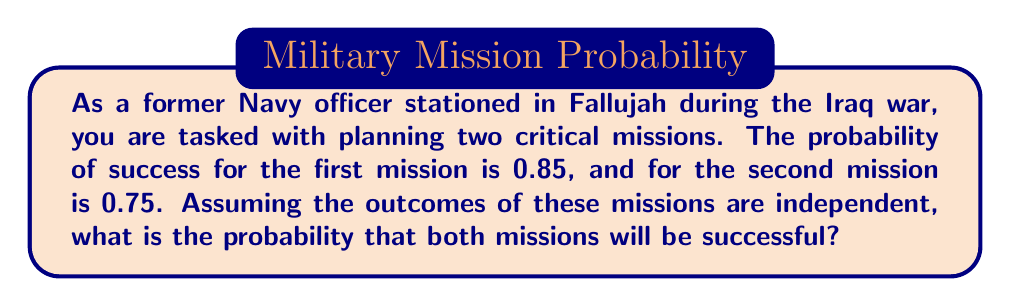What is the answer to this math problem? To solve this problem, we need to use the concept of compound events and the multiplication rule for independent events.

1) Let's define our events:
   A = Success of the first mission
   B = Success of the second mission

2) We're given:
   P(A) = 0.85
   P(B) = 0.75

3) We want to find P(A and B), the probability that both missions are successful.

4) Since the missions are independent, we can use the multiplication rule for independent events:

   $$P(A \text{ and } B) = P(A) \cdot P(B)$$

5) Substituting the given probabilities:

   $$P(A \text{ and } B) = 0.85 \cdot 0.75$$

6) Calculating:

   $$P(A \text{ and } B) = 0.6375$$

Therefore, the probability that both missions will be successful is 0.6375 or 63.75%.
Answer: The probability that both missions will be successful is 0.6375 or 63.75%. 